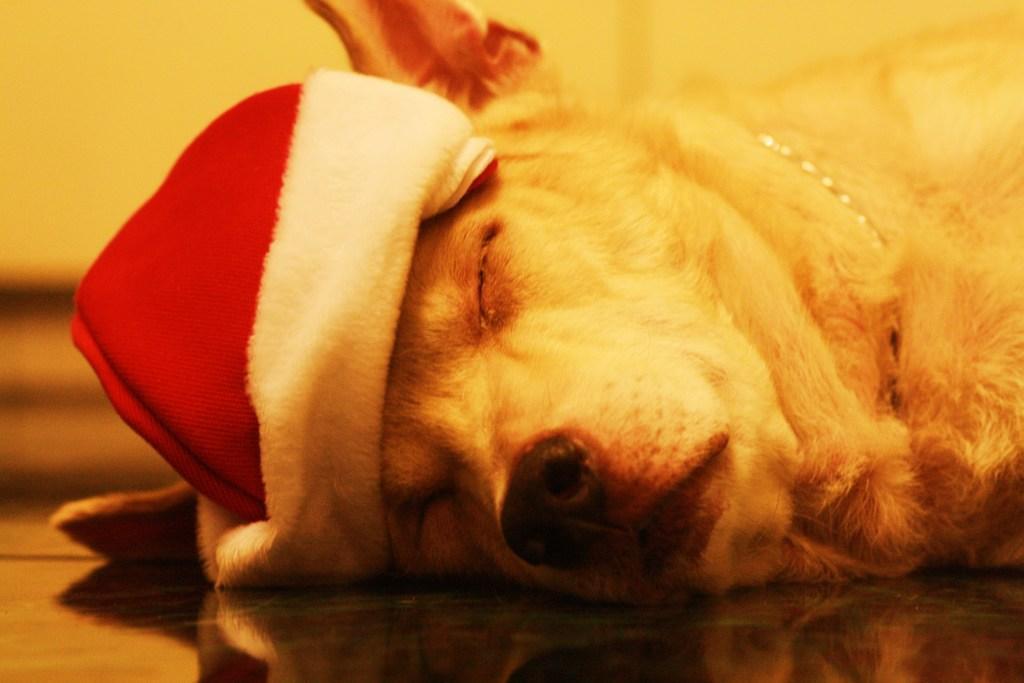Could you give a brief overview of what you see in this image? In this image we can see that there is a dog which is sleeping on the floor by wearing the red color cap. 